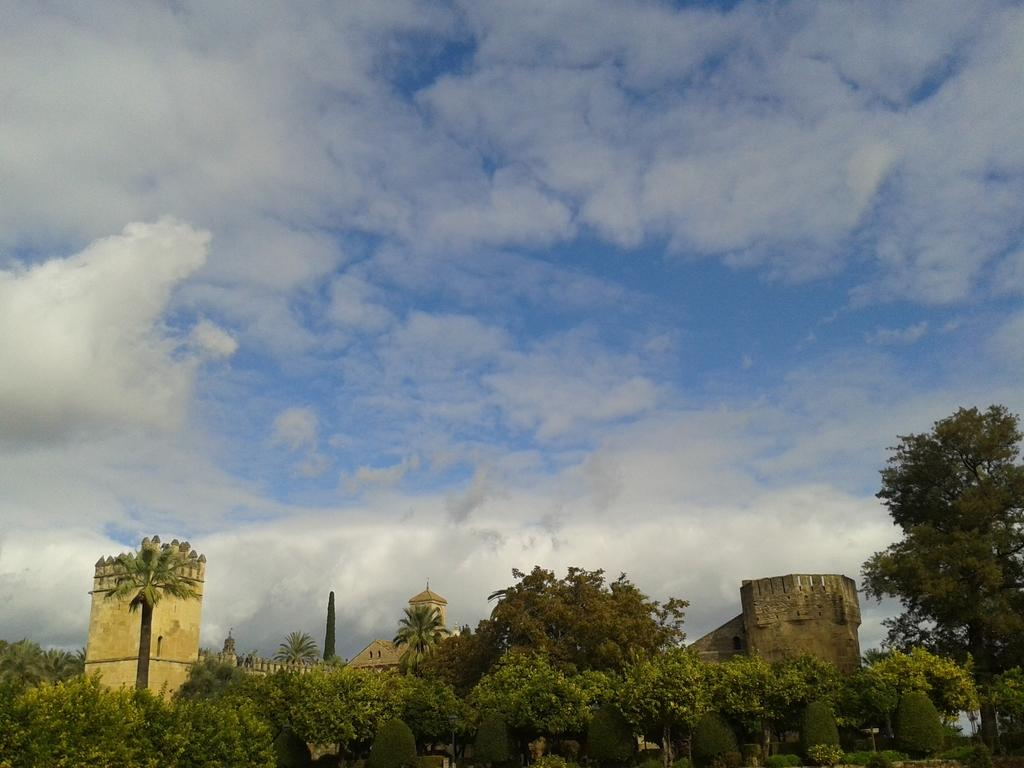What is located at the bottom of the image? There are trees and a monument at the bottom of the image. What can be seen in the sky in the image? The sky is covered with clouds in the image. What type of transport can be seen in the image? There is no transport visible in the image; it only features trees, a monument, and clouds. Is there a picture of a potato in the image? No, there is no picture of a potato in the image. 